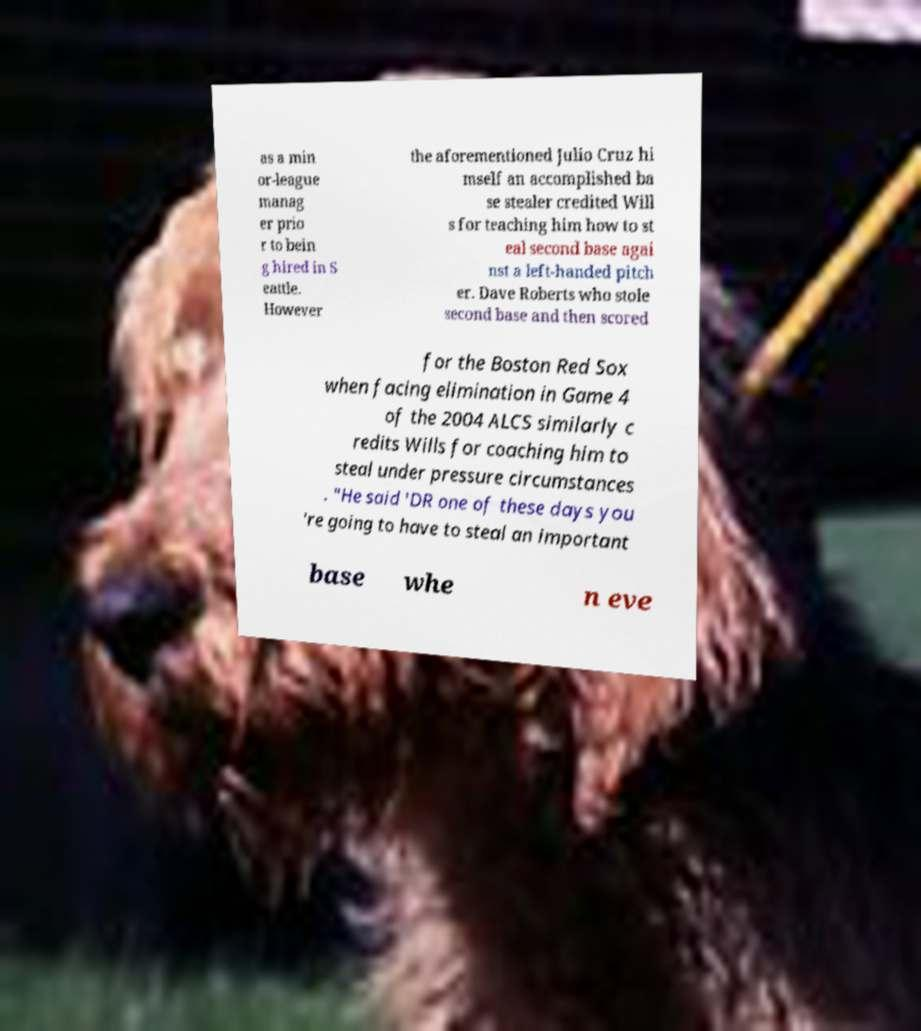Could you extract and type out the text from this image? as a min or-league manag er prio r to bein g hired in S eattle. However the aforementioned Julio Cruz hi mself an accomplished ba se stealer credited Will s for teaching him how to st eal second base agai nst a left-handed pitch er. Dave Roberts who stole second base and then scored for the Boston Red Sox when facing elimination in Game 4 of the 2004 ALCS similarly c redits Wills for coaching him to steal under pressure circumstances . "He said 'DR one of these days you 're going to have to steal an important base whe n eve 